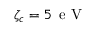<formula> <loc_0><loc_0><loc_500><loc_500>\zeta _ { c } = 5 \, e V</formula> 